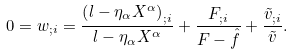<formula> <loc_0><loc_0><loc_500><loc_500>0 = w _ { ; i } = \frac { \left ( l - \eta _ { \alpha } X ^ { \alpha } \right ) _ { ; i } } { l - \eta _ { \alpha } X ^ { \alpha } } + \frac { F _ { ; i } } { F - \hat { f } } + \frac { \tilde { v } _ { ; i } } { \tilde { v } } .</formula> 